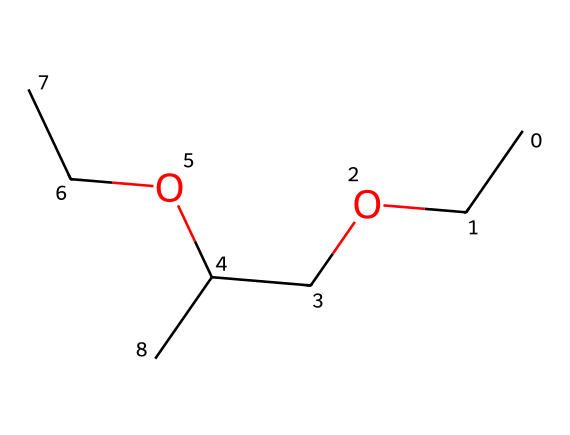What is the total number of carbon atoms in the chemical? By inspecting the SMILES representation, we can count the distinct 'C' characters representing carbon atoms. There are a total of 6 'C' characters.
Answer: 6 How many hydroxyl (OH) functional groups are present in the structure? In the provided SMILES, the '(OCC)' indicates a hydroxyl group attached to an ethyl group, and there is only one occurrence of this OH presence.
Answer: 1 Which type of functional group distinguishes this chemical as an ether? The presence of the 'CCOCC' part of the SMILES indicates that there are alkyl groups bonded through an oxygen atom, defining it as an ether.
Answer: ether What is the molecular formula derived from this structure? By counting all the atoms represented in the SMILES, we can deduce the molecular formula is C6H14O2. This is achieved by adding up all carbon, hydrogen, and oxygen atoms from the structure.
Answer: C6H14O2 Which two types of bonds can be found in the structure? The chemical structure likely contains carbon-carbon (C-C) and carbon-oxygen (C-O) bonds, as implied by the linked carbon atoms that are connected by single bonds and the oxygen that connects them as part of the ether formation.
Answer: C-C, C-O What is the significance of the terminal ethyl groups in this chemical? The terminal ethyl groups help in determining the solubility and volatility characteristics of the ether compound, making it more effective as a solvent. The structure impacts how it interacts with other substances.
Answer: solvent effectiveness 